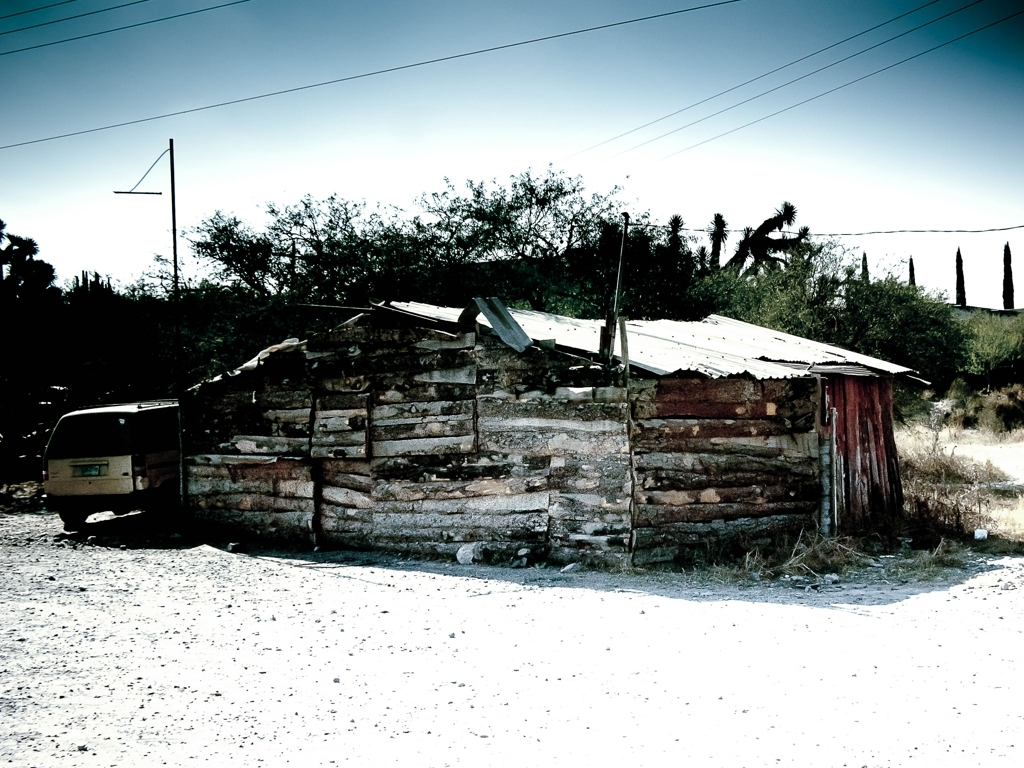Describe the overall mood or atmosphere this image might convey. The image exudes a sense of desolation and abandonment. The stark lighting and the solitary, dilapidated building invoke feelings of isolation and the passage of time. 